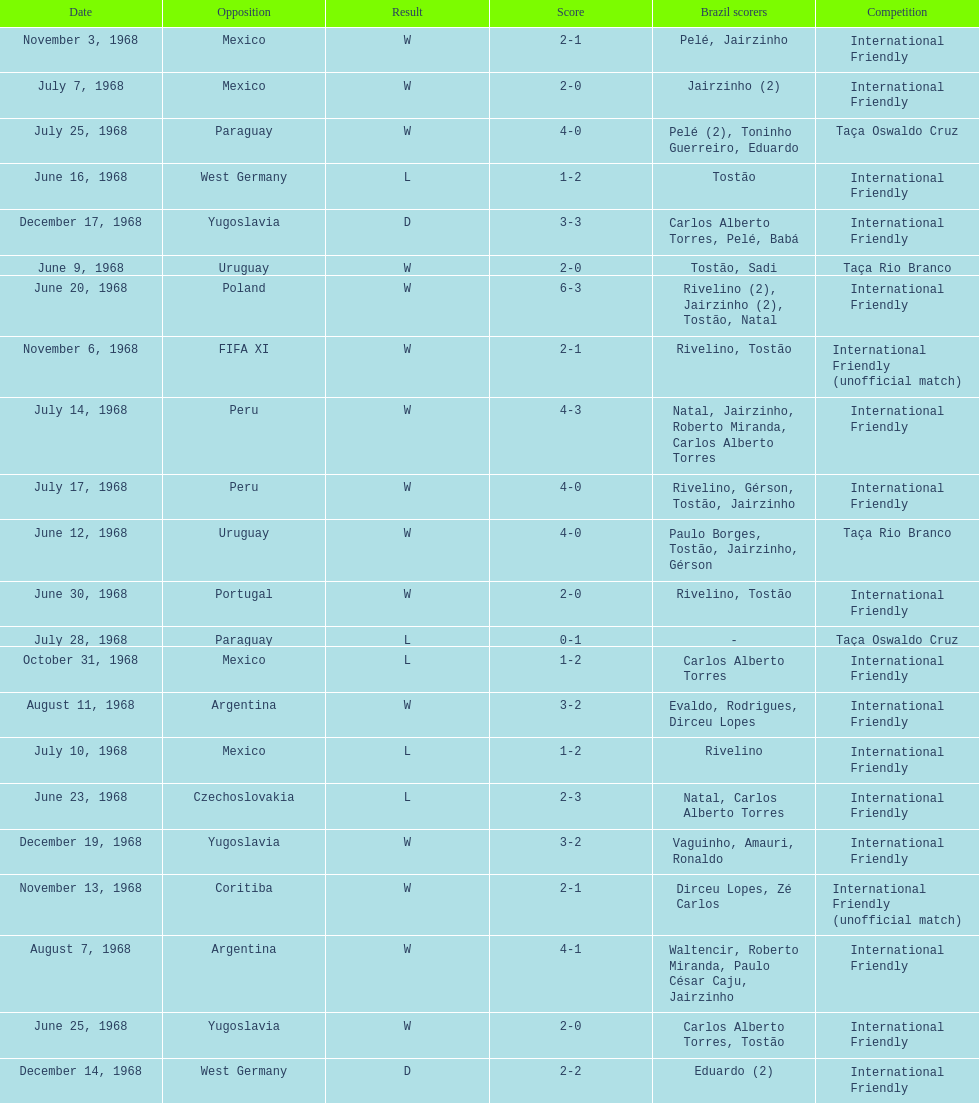How many times did brazil play against argentina in the international friendly competition? 2. 